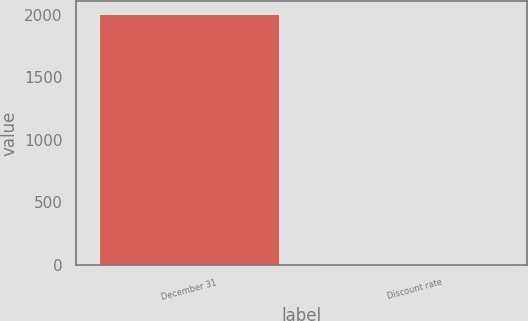<chart> <loc_0><loc_0><loc_500><loc_500><bar_chart><fcel>December 31<fcel>Discount rate<nl><fcel>2006<fcel>5.7<nl></chart> 